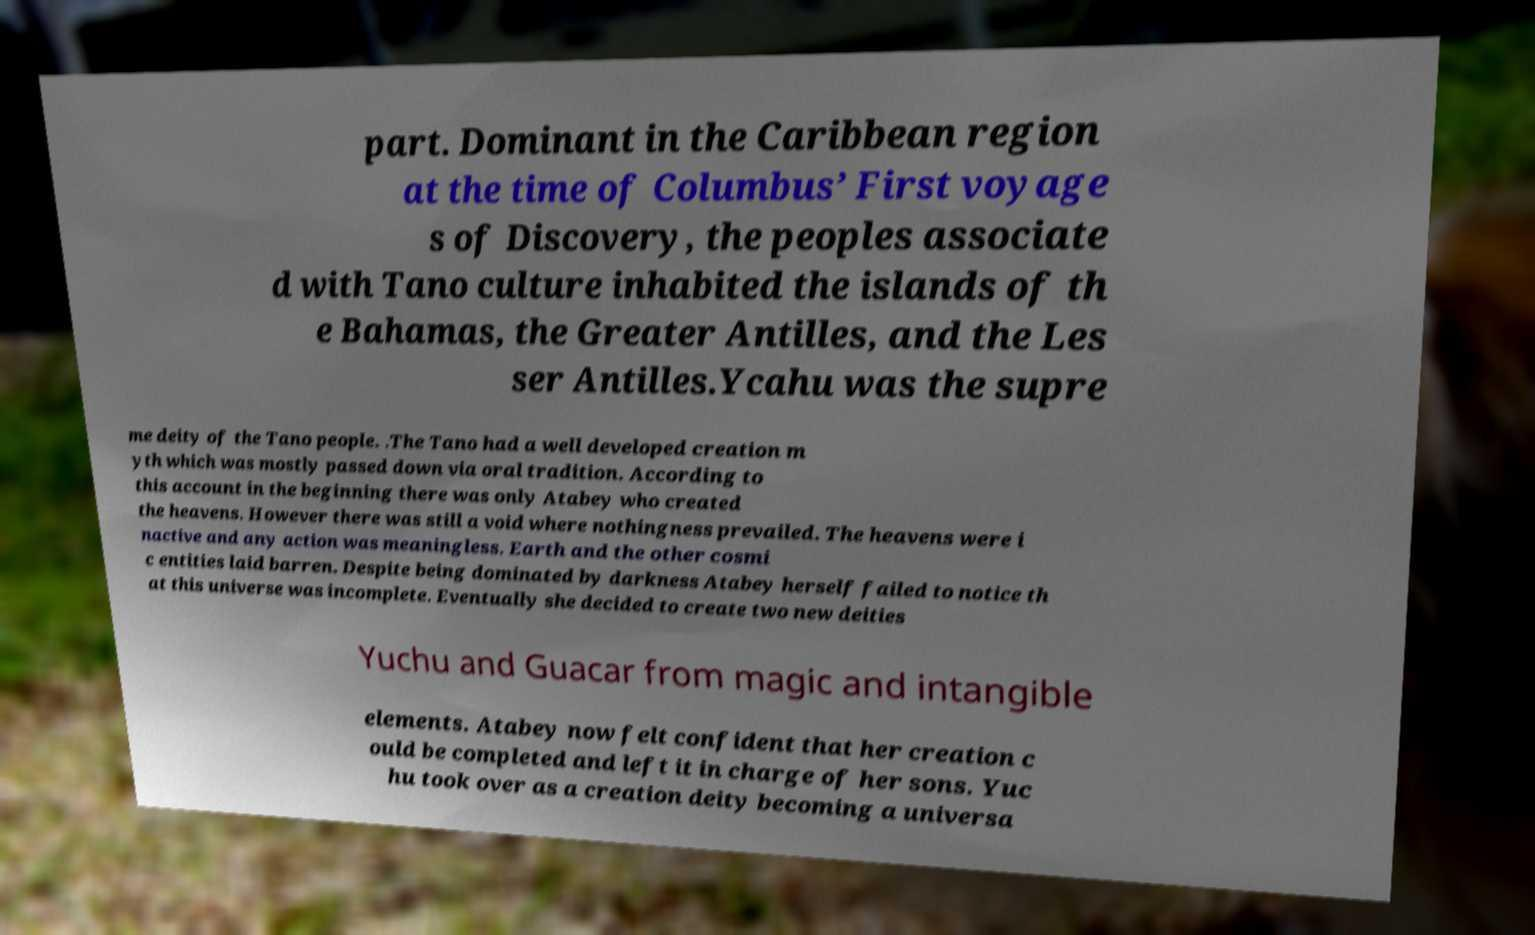Please read and relay the text visible in this image. What does it say? part. Dominant in the Caribbean region at the time of Columbus’ First voyage s of Discovery, the peoples associate d with Tano culture inhabited the islands of th e Bahamas, the Greater Antilles, and the Les ser Antilles.Ycahu was the supre me deity of the Tano people. .The Tano had a well developed creation m yth which was mostly passed down via oral tradition. According to this account in the beginning there was only Atabey who created the heavens. However there was still a void where nothingness prevailed. The heavens were i nactive and any action was meaningless. Earth and the other cosmi c entities laid barren. Despite being dominated by darkness Atabey herself failed to notice th at this universe was incomplete. Eventually she decided to create two new deities Yuchu and Guacar from magic and intangible elements. Atabey now felt confident that her creation c ould be completed and left it in charge of her sons. Yuc hu took over as a creation deity becoming a universa 